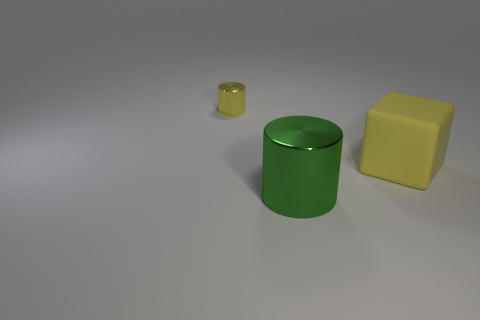Add 1 yellow metal things. How many objects exist? 4 Subtract all blocks. How many objects are left? 2 Subtract 0 green cubes. How many objects are left? 3 Subtract all yellow shiny objects. Subtract all large yellow cubes. How many objects are left? 1 Add 1 big yellow cubes. How many big yellow cubes are left? 2 Add 2 green metallic cylinders. How many green metallic cylinders exist? 3 